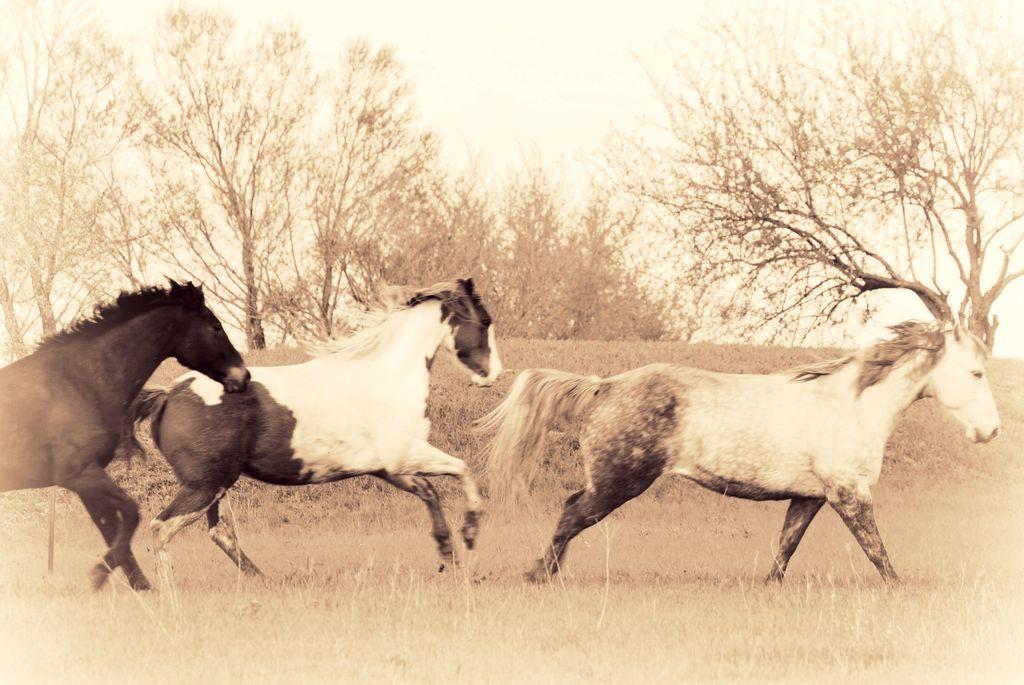What animals are present on the ground in the image? There are horses on the ground in the image. What type of natural scenery can be seen in the background of the image? There are trees visible in the background of the image. What type of marble is used for the caption in the image? There is no caption present in the image, and therefore no marble can be associated with it. 